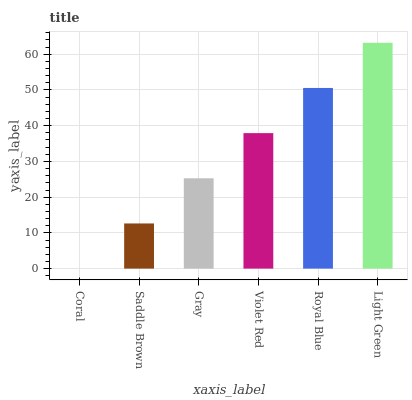Is Coral the minimum?
Answer yes or no. Yes. Is Light Green the maximum?
Answer yes or no. Yes. Is Saddle Brown the minimum?
Answer yes or no. No. Is Saddle Brown the maximum?
Answer yes or no. No. Is Saddle Brown greater than Coral?
Answer yes or no. Yes. Is Coral less than Saddle Brown?
Answer yes or no. Yes. Is Coral greater than Saddle Brown?
Answer yes or no. No. Is Saddle Brown less than Coral?
Answer yes or no. No. Is Violet Red the high median?
Answer yes or no. Yes. Is Gray the low median?
Answer yes or no. Yes. Is Coral the high median?
Answer yes or no. No. Is Saddle Brown the low median?
Answer yes or no. No. 